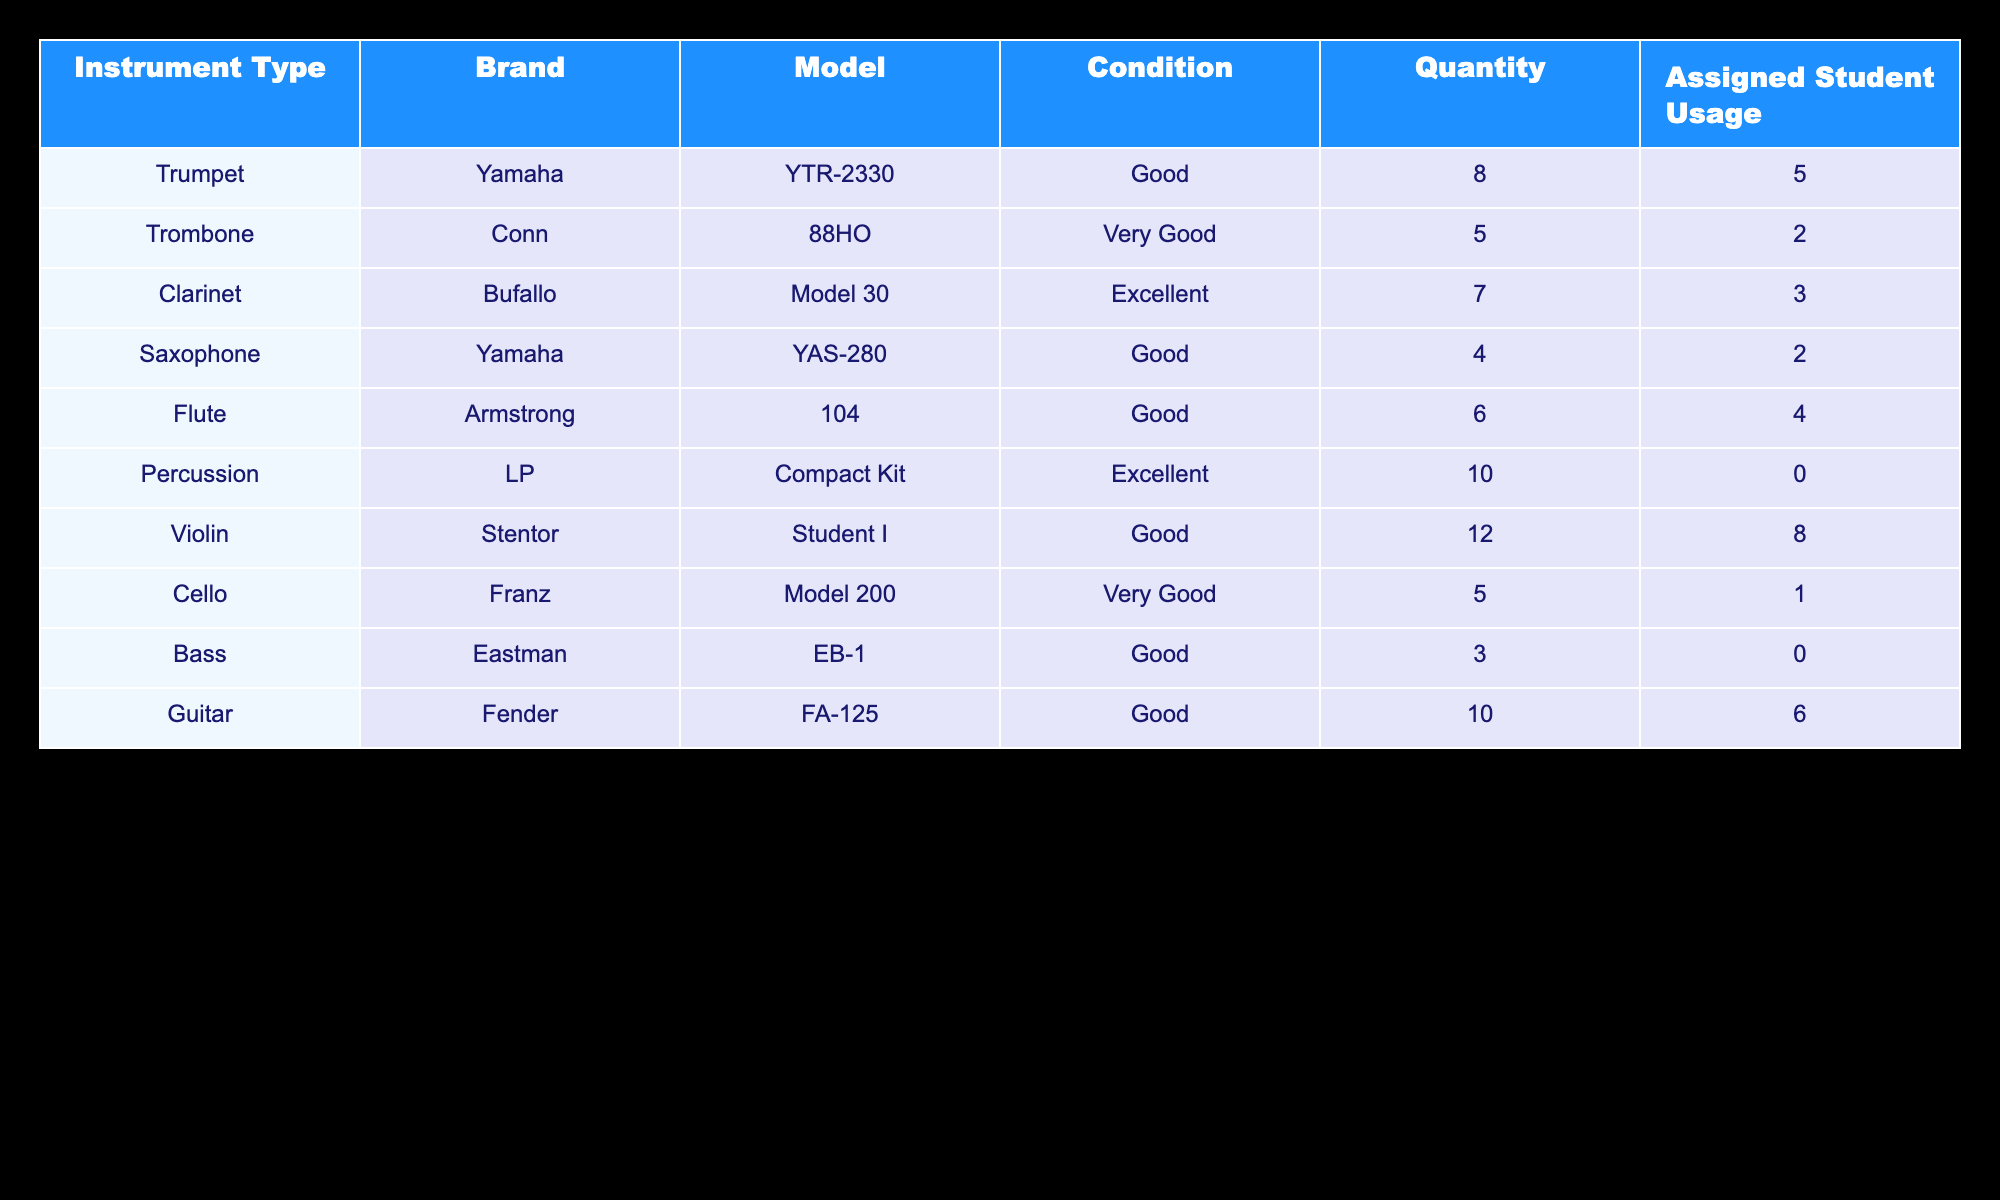What is the total number of trumpets available for student use? The table shows that there are 8 trumpets under the instrument type column. The quantity column corresponding to trumpets states the total available, which is 8.
Answer: 8 How many clarinets are assigned to students? According to the table, the assigned student usage column for clarinets indicates that 3 are currently assigned to students.
Answer: 3 Which instrument has the highest quantity available? By comparing the quantity column for each instrument, the violin has the highest quantity of 12 available.
Answer: Violin What is the average number of instruments assigned to students across all instrument types? To determine the average, first sum the assigned student usage values: 5 (trumpets) + 2 (trombones) + 3 (clarinets) + 2 (saxophones) + 4 (flutes) + 0 (percussions) + 8 (violins) + 1 (cellos) + 0 (basses) + 6 (guitars) = 31. There are 10 instruments listed, so the average is 31/10 = 3.1 assigned instruments per type.
Answer: 3.1 Is there any instrument that has zero assigned student usage? Looking at the assigned student usage column, both percussion instruments and bass instruments show a usage of 0, confirming that there are indeed instruments without any student assignments.
Answer: Yes How many flutes are available compared to the total number of clarinets? The table shows there are 6 flutes and 7 clarinets. To compare, there are fewer flutes than clarinets since 6 is less than 7.
Answer: Fewer flutes What is the combined quantity of string instruments? The string instruments present are violins (12), cellos (5), and basses (3). Adding these together: 12 + 5 + 3 = 20. Thus, there are a total of 20 string instruments.
Answer: 20 Are there any instruments considered to be in excellent condition? The condition column indicates that both clarinets and percussion instruments are marked as excellent, confirming that there are instruments in that condition.
Answer: Yes How many more guitars are available compared to trombones? The table states that there are 10 guitars and 5 trombones. Finding the difference: 10 - 5 = 5, indicating that there are 5 more guitars than trombones.
Answer: 5 